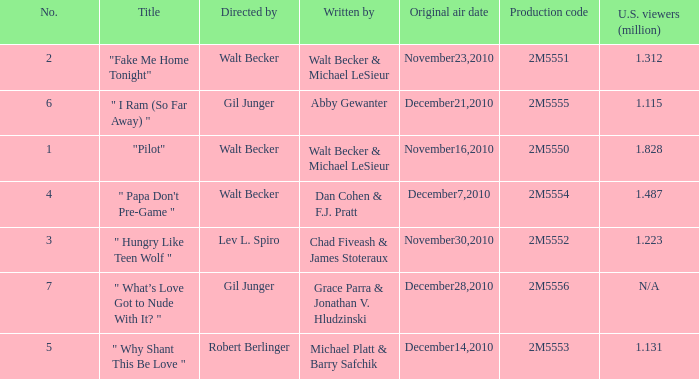How many million U.S. viewers saw "Fake Me Home Tonight"? 1.312. 